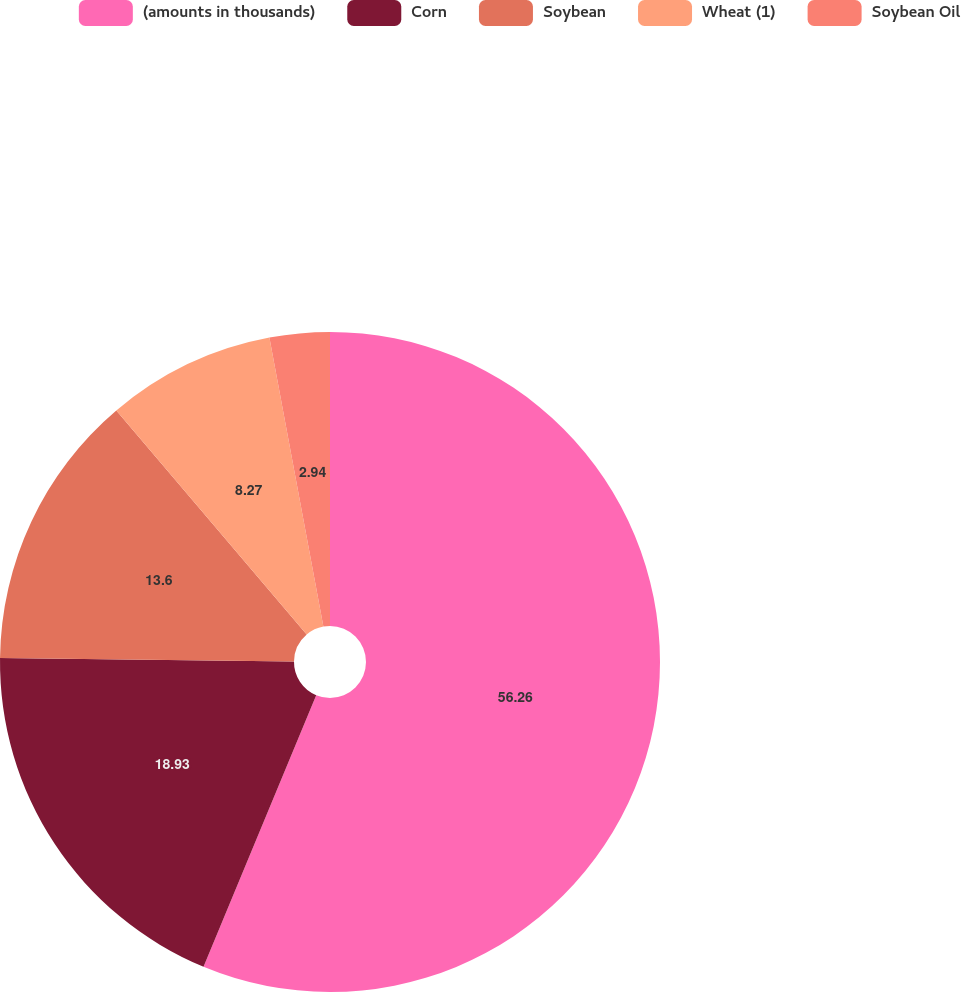Convert chart to OTSL. <chart><loc_0><loc_0><loc_500><loc_500><pie_chart><fcel>(amounts in thousands)<fcel>Corn<fcel>Soybean<fcel>Wheat (1)<fcel>Soybean Oil<nl><fcel>56.26%<fcel>18.93%<fcel>13.6%<fcel>8.27%<fcel>2.94%<nl></chart> 